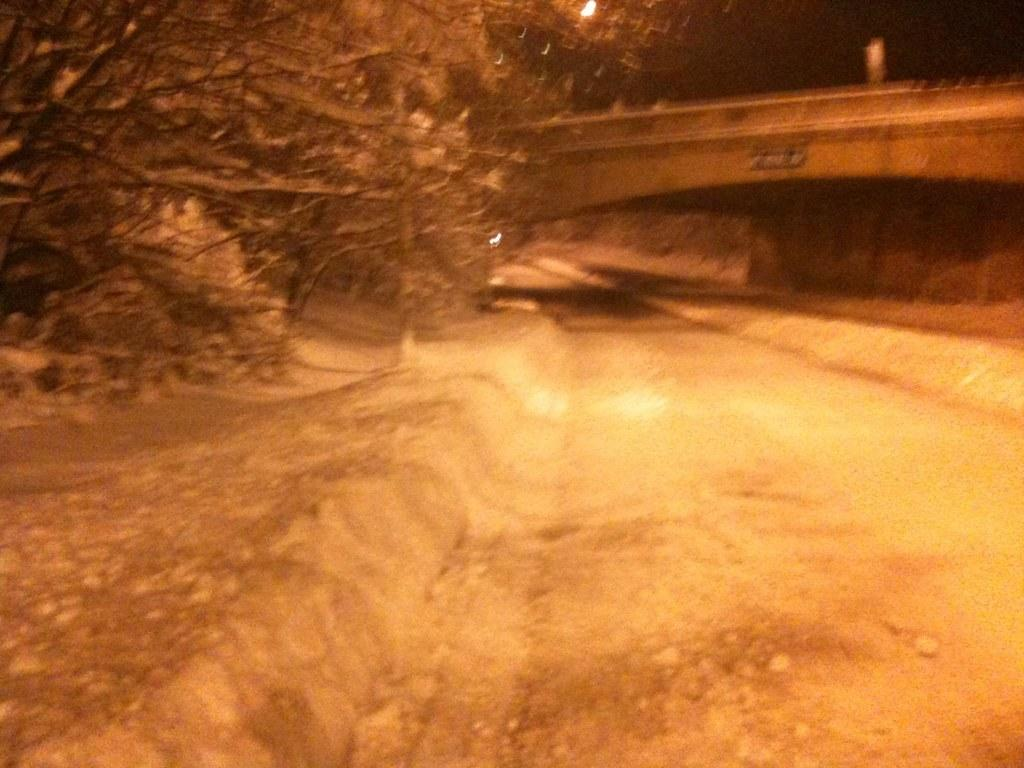What type of structure is present in the image? There is a bridge in the image. What type of vegetation can be seen in the image? There are trees in the image. What type of lighting is present in the image? There is a street light in the image. What type of pathway is present in the image? There is a road in the image. What part of the natural environment is visible in the image? The sky is visible in the top right corner of the image. Where is the office located in the image? There is no office present in the image. What type of tray is visible in the image? There is no tray present in the image. 